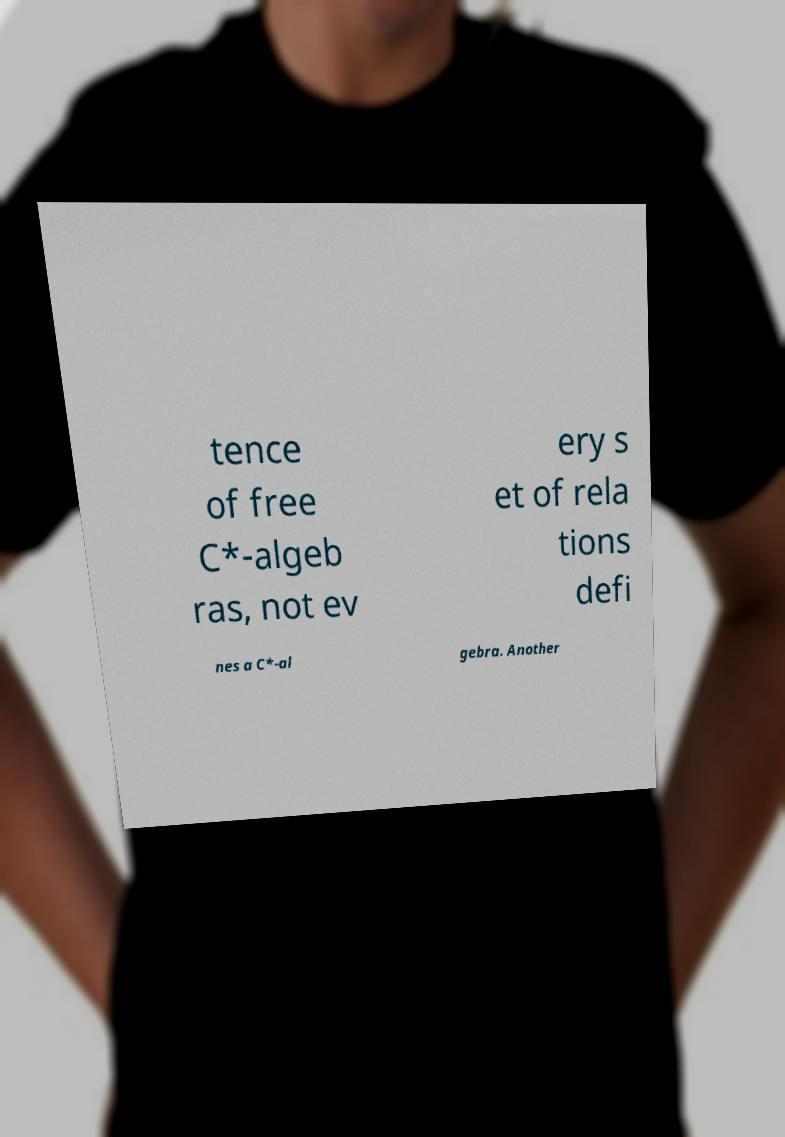What messages or text are displayed in this image? I need them in a readable, typed format. tence of free C*-algeb ras, not ev ery s et of rela tions defi nes a C*-al gebra. Another 